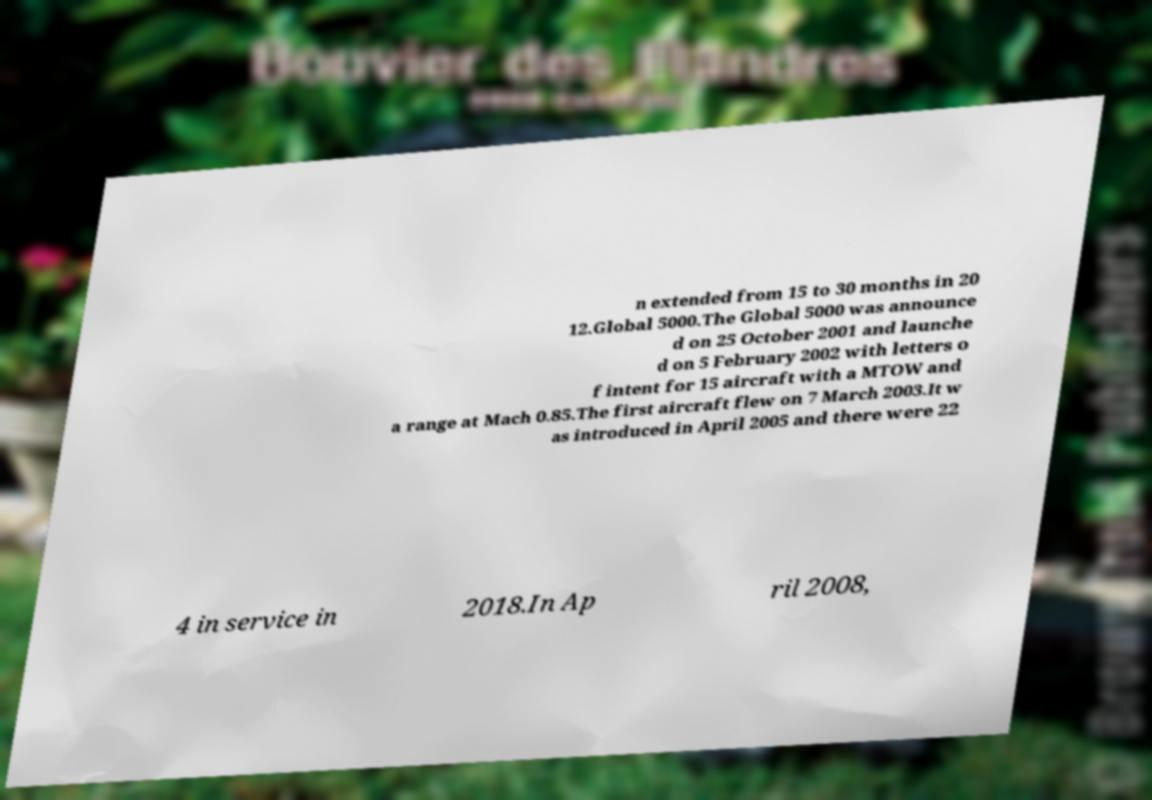Could you extract and type out the text from this image? n extended from 15 to 30 months in 20 12.Global 5000.The Global 5000 was announce d on 25 October 2001 and launche d on 5 February 2002 with letters o f intent for 15 aircraft with a MTOW and a range at Mach 0.85.The first aircraft flew on 7 March 2003.It w as introduced in April 2005 and there were 22 4 in service in 2018.In Ap ril 2008, 